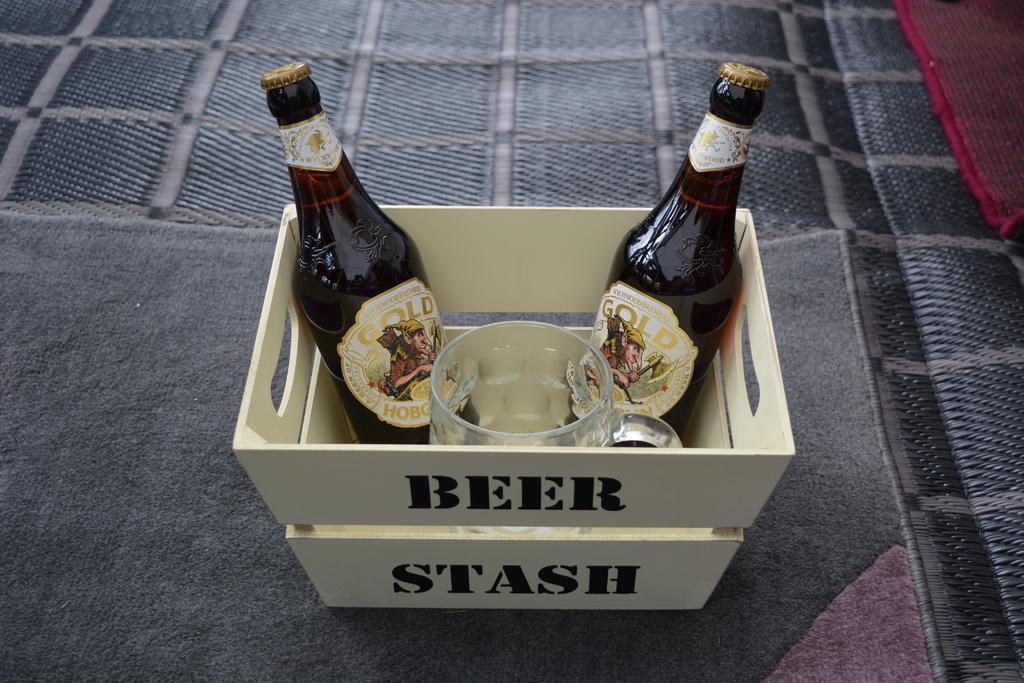What is the name of this basket?
Your response must be concise. Beer stash. What brand of beer is in the basket?
Your answer should be very brief. Gold. 